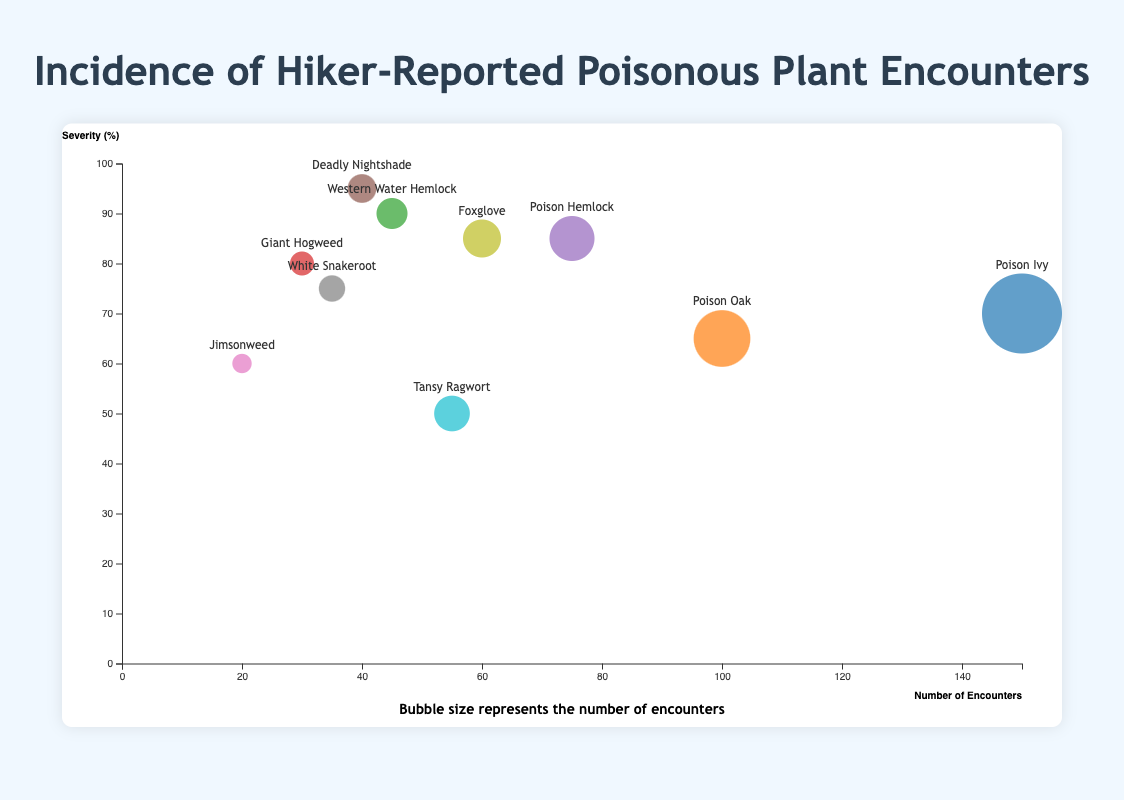Which plant species is encountered the most by hikers? The horizontal axis represents the number of encounters. The biggest bubble, which indicates the highest number of encounters, corresponds to "Poison Ivy" with 150 encounters.
Answer: Poison Ivy Which plant species does the color blue represent? Each color represents a different plant species. As per the color legend in the figure, the color blue corresponds to "Poison Hemlock".
Answer: Poison Hemlock Which location reports the highest severity for plant encounters? The vertical axis represents the severity percentage. The highest point on this axis corresponds to "Deadly Nightshade" in Yosemite National Park, which has a severity of 95%.
Answer: Yosemite National Park What is the average severity of encounters for plants located in national parks? The bubble chart provides the severities for several national parks: Rock Mountain (90), Yosemite (95), Zion (60), Shenandoah (75), Olympic (85), and Yellowstone (50). Sum these and divide by the number of parks: (90+95+60+75+85+50) / 6 = 455 / 6 ≈ 75.83.
Answer: 75.83 Are the severities for Poison Hemlock and Foxglove the same, or different? Find each plant on the vertical axis: Poison Hemlock has a severity of 85%, and Foxglove also has a severity of 85%. Therefore, they are the same.
Answer: Same How does the number of Poison Ivy encounters compare with Poison Oak? Poison Ivy has 150 encounters, and Poison Oak has 100. Comparing these numbers shows that Poison Ivy has more encounters than Poison Oak.
Answer: Poison Ivy has more What is the median severity of all the plants listed? First, list the severities from least to greatest: 50, 60, 65, 70, 75, 80, 85, 85, 90, 95. The median is the middle value in an even list: (75 + 80) / 2 = 77.5.
Answer: 77.5 Which plant species has the smallest bubble on the chart? The bubble size represents the number of encounters. The smallest bubble corresponds to "Jimsonweed" with the fewest encounters, 20.
Answer: Jimsonweed Which plant species has the closest severity to 80%? Identify the plants along the vertical axis; "Giant Hogweed" has a severity of 80%. There are no other plants with this exact value.
Answer: Giant Hogweed 